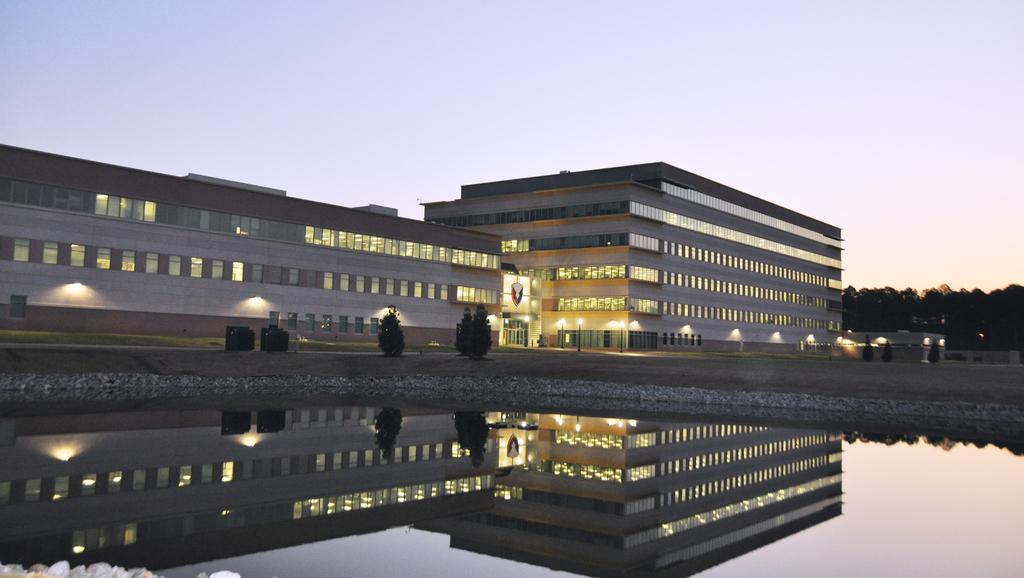What is the primary element visible in the image? There is water in the image. What type of natural elements can be seen in the image? There are trees in the image. What type of man-made structure is present in the image? There is a building in the image. What type of illumination is present in the image? There are lights in the image. What can be seen in the background of the image? The sky is visible in the background of the image. Can you tell me what type of lettuce is being served by the father in the image? There is no father or lettuce present in the image. 